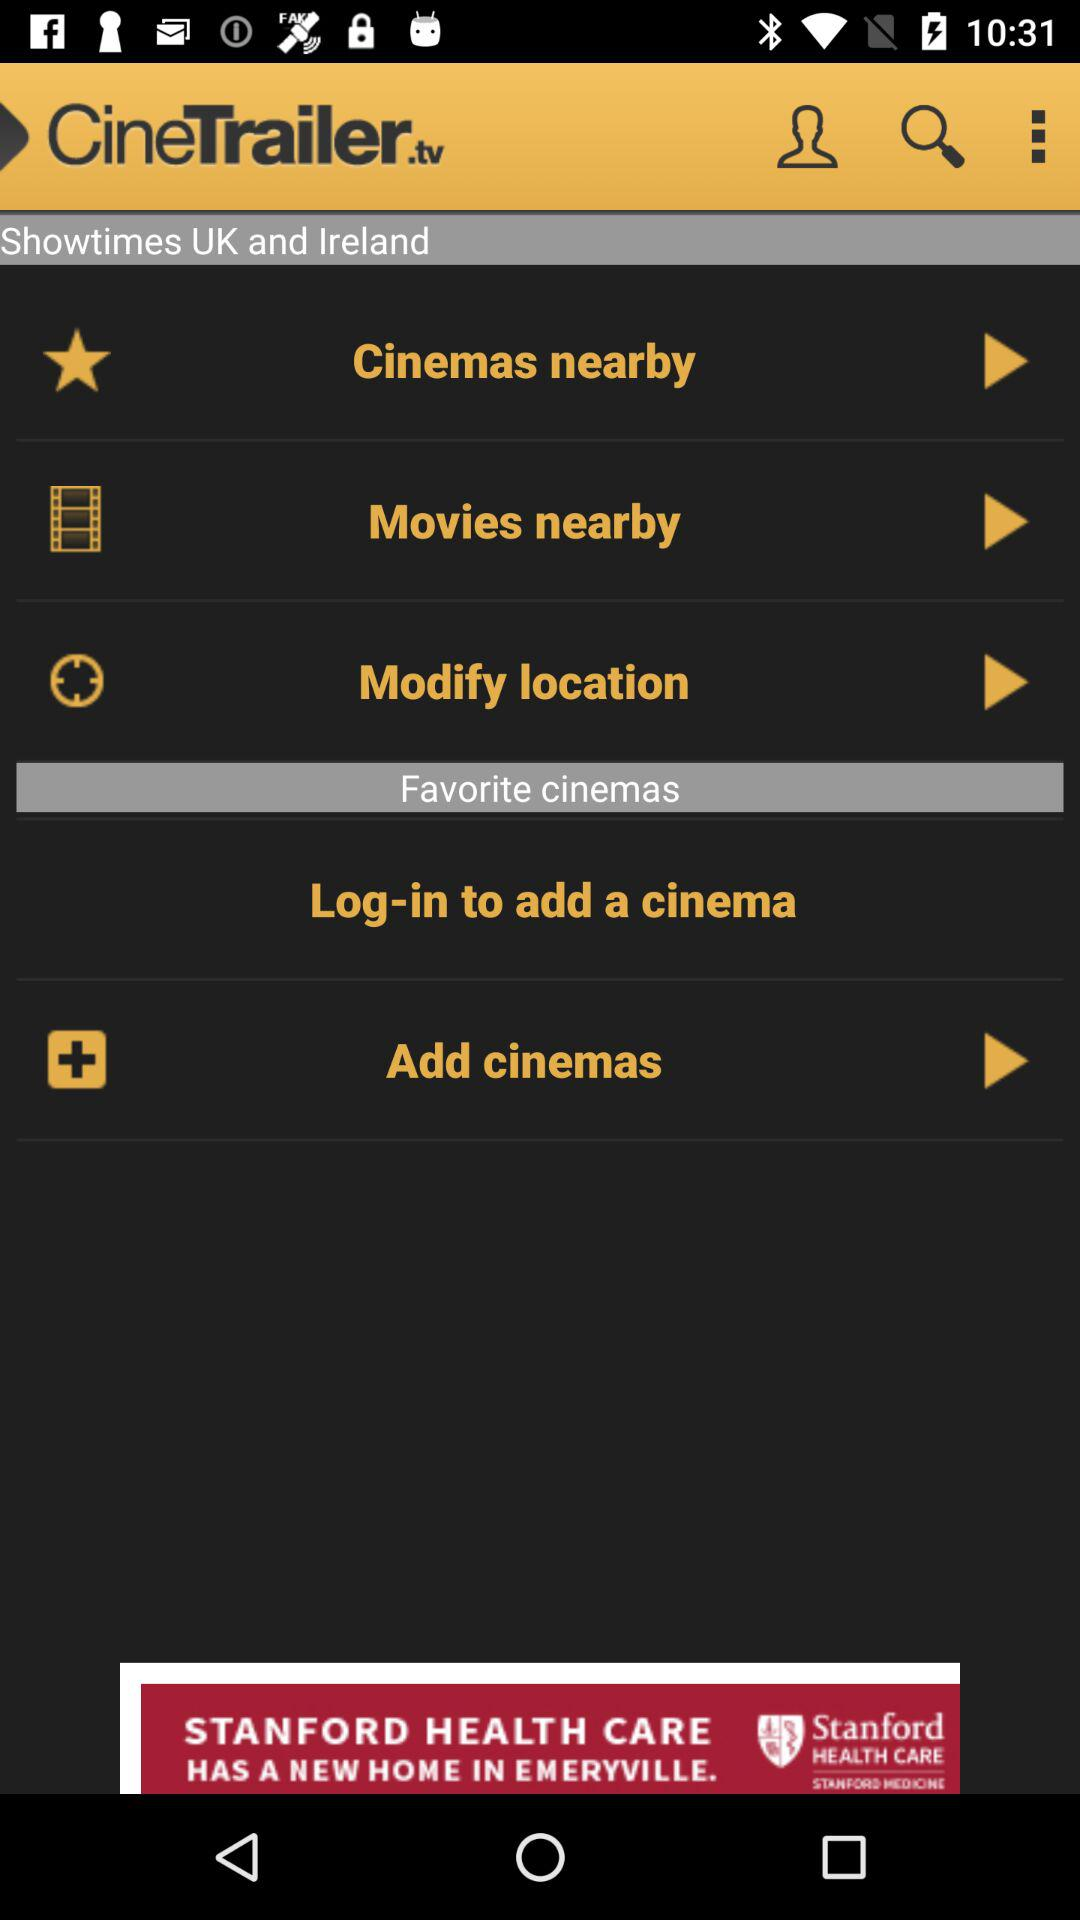Which cinemas are nearby?
When the provided information is insufficient, respond with <no answer>. <no answer> 